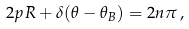Convert formula to latex. <formula><loc_0><loc_0><loc_500><loc_500>2 p R + \delta ( \theta - \theta _ { B } ) = 2 n \pi \, ,</formula> 